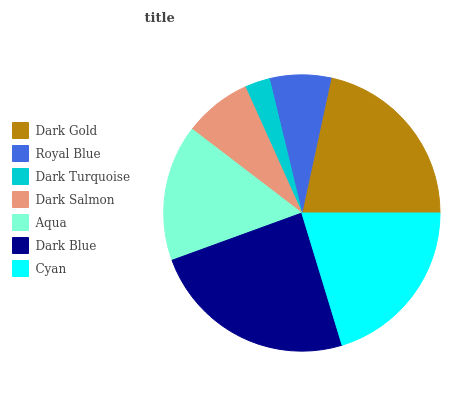Is Dark Turquoise the minimum?
Answer yes or no. Yes. Is Dark Blue the maximum?
Answer yes or no. Yes. Is Royal Blue the minimum?
Answer yes or no. No. Is Royal Blue the maximum?
Answer yes or no. No. Is Dark Gold greater than Royal Blue?
Answer yes or no. Yes. Is Royal Blue less than Dark Gold?
Answer yes or no. Yes. Is Royal Blue greater than Dark Gold?
Answer yes or no. No. Is Dark Gold less than Royal Blue?
Answer yes or no. No. Is Aqua the high median?
Answer yes or no. Yes. Is Aqua the low median?
Answer yes or no. Yes. Is Dark Turquoise the high median?
Answer yes or no. No. Is Dark Gold the low median?
Answer yes or no. No. 